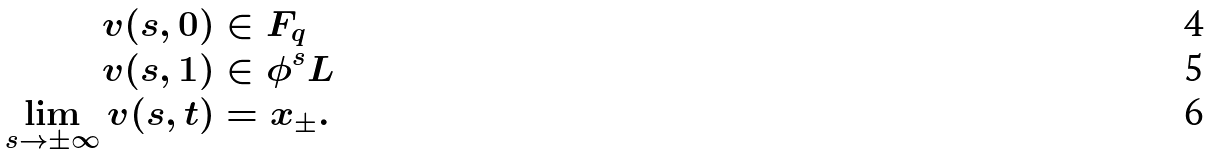<formula> <loc_0><loc_0><loc_500><loc_500>v ( s , 0 ) & \in F _ { q } \\ v ( s , 1 ) & \in \phi ^ { s } L \\ \lim _ { s \to \pm \infty } v ( s , t ) & = x _ { \pm } .</formula> 